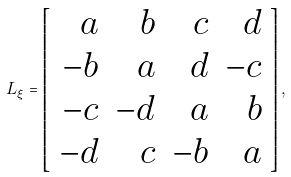<formula> <loc_0><loc_0><loc_500><loc_500>L _ { \xi } = \left [ \begin{array} { r r r r } a & b & c & d \\ - b & a & d & - c \\ - c & - d & a & b \\ - d & c & - b & a \end{array} \right ] ,</formula> 